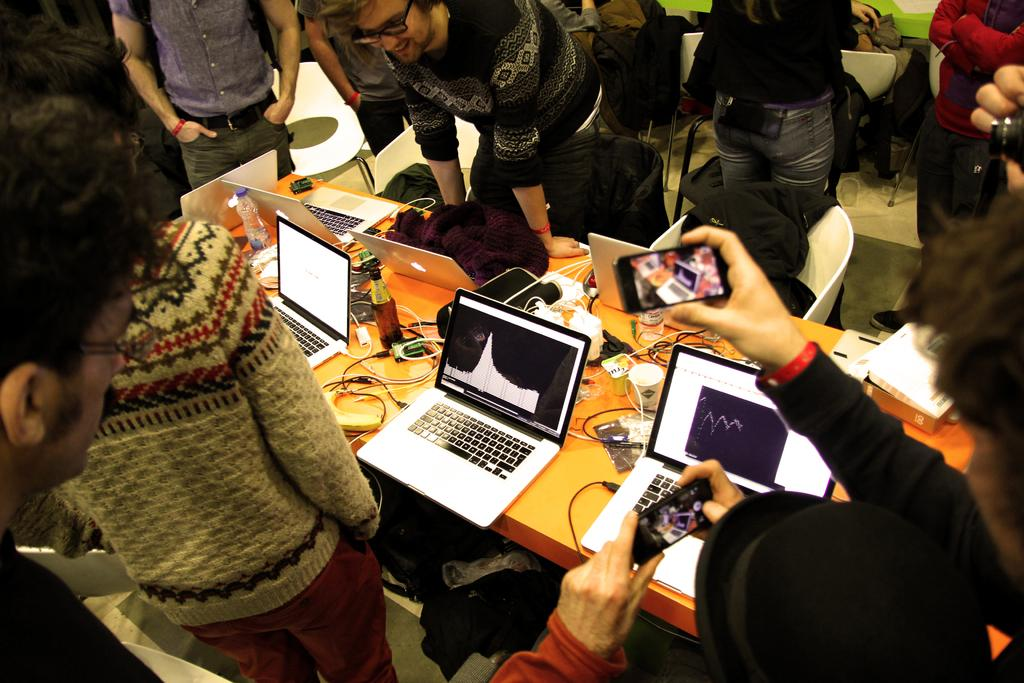How many people are in the image? There is a group of people in the image. What furniture is present in the image? There is a chair and a table in the image. What electronic devices can be seen on the table? On the table, there is a laptop, a bottle, a cup, and wires. What is the man holding in the image? The man is holding a mobile in the image. What type of curtain is hanging in front of the window in the image? There is no window or curtain present in the image. How does the fog affect the visibility of the objects in the image? There is no fog present in the image; the visibility of the objects is clear. 